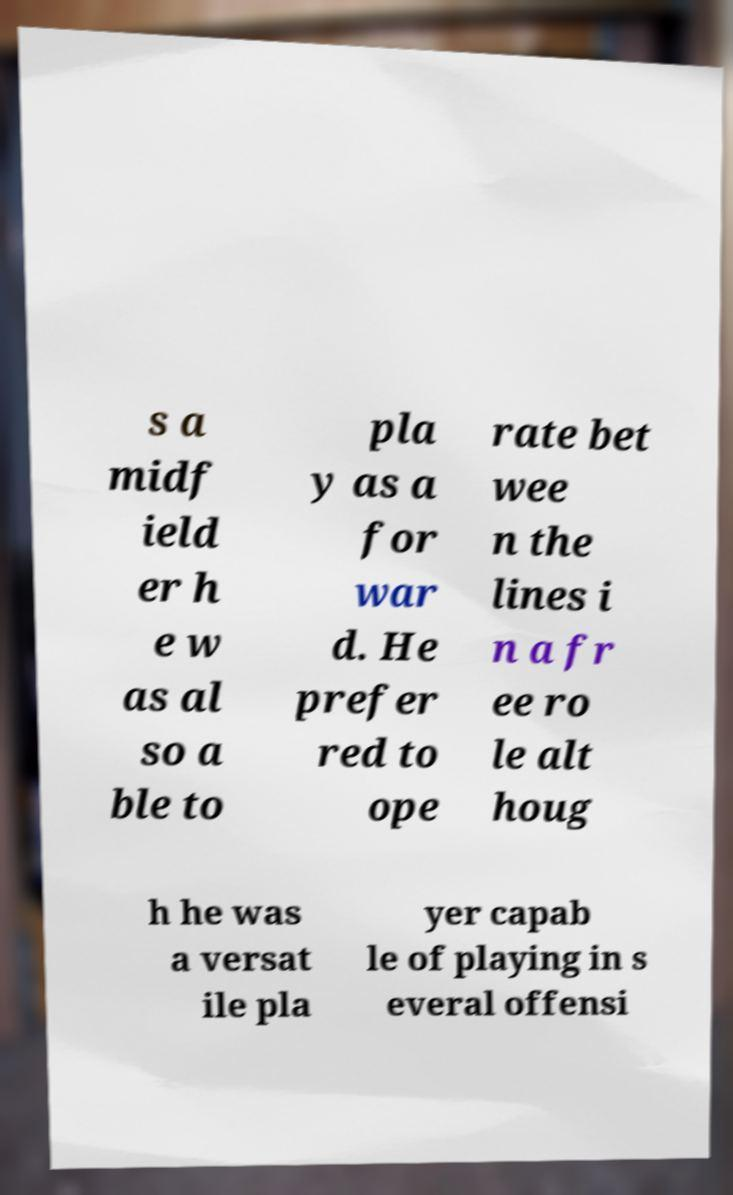I need the written content from this picture converted into text. Can you do that? s a midf ield er h e w as al so a ble to pla y as a for war d. He prefer red to ope rate bet wee n the lines i n a fr ee ro le alt houg h he was a versat ile pla yer capab le of playing in s everal offensi 